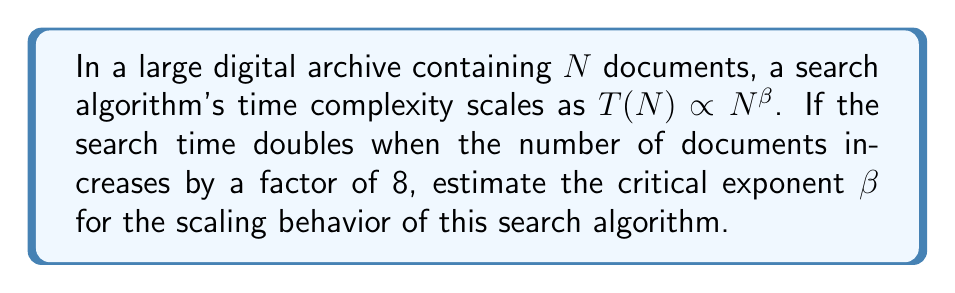Give your solution to this math problem. To solve this problem, we'll follow these steps:

1) The scaling behavior is given by $T(N) \propto N^{\beta}$, where $\beta$ is the critical exponent we need to find.

2) We're told that when the number of documents increases by a factor of 8, the search time doubles. Let's express this mathematically:

   $T(8N) = 2T(N)$

3) Using the scaling relation, we can write:
   
   $(8N)^{\beta} = 2N^{\beta}$

4) Simplify the left side:
   
   $8^{\beta}N^{\beta} = 2N^{\beta}$

5) The $N^{\beta}$ terms cancel out:

   $8^{\beta} = 2$

6) Take the logarithm (base 2) of both sides:

   $\log_2(8^{\beta}) = \log_2(2)$

7) Use the logarithm property $\log_a(x^n) = n\log_a(x)$:

   $\beta \log_2(8) = 1$

8) Simplify $\log_2(8) = 3$:

   $3\beta = 1$

9) Solve for $\beta$:

   $\beta = \frac{1}{3}$

Therefore, the critical exponent $\beta$ for the scaling behavior of this search algorithm is $\frac{1}{3}$.
Answer: $\beta = \frac{1}{3}$ 